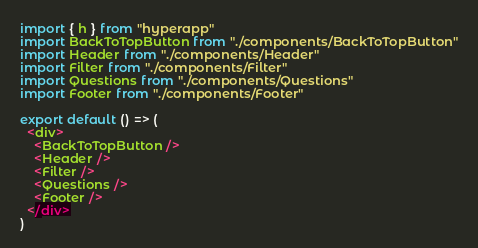Convert code to text. <code><loc_0><loc_0><loc_500><loc_500><_JavaScript_>import { h } from "hyperapp"
import BackToTopButton from "./components/BackToTopButton"
import Header from "./components/Header"
import Filter from "./components/Filter"
import Questions from "./components/Questions"
import Footer from "./components/Footer"

export default () => (
  <div>
    <BackToTopButton />
    <Header />
    <Filter />
    <Questions />
    <Footer />
  </div>
)
</code> 